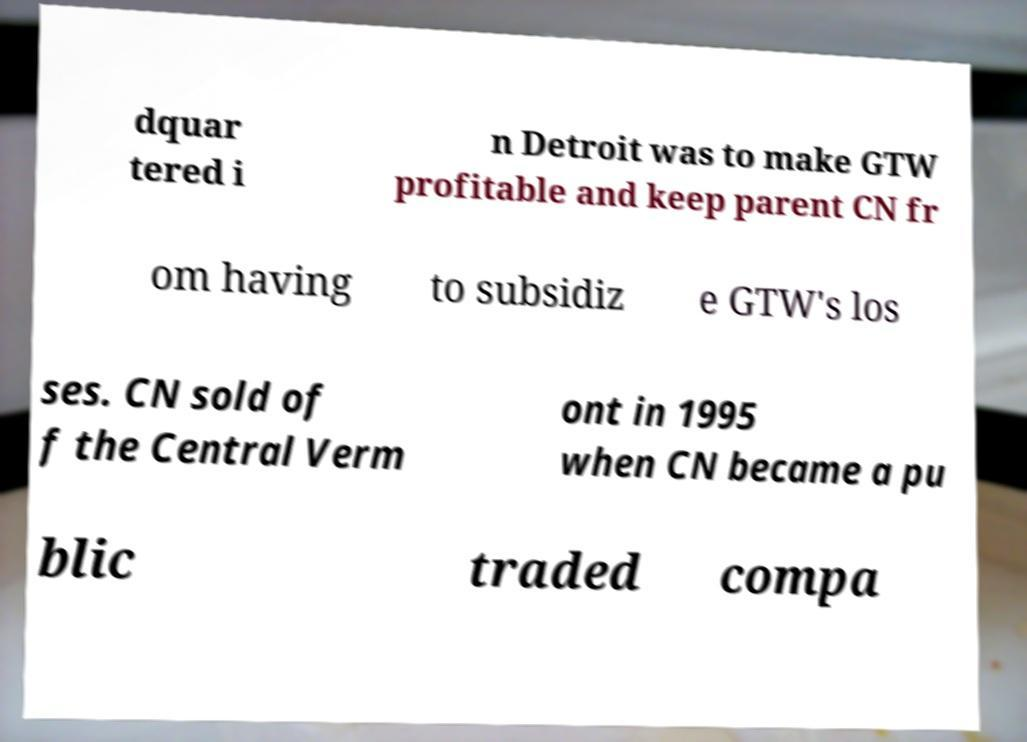There's text embedded in this image that I need extracted. Can you transcribe it verbatim? dquar tered i n Detroit was to make GTW profitable and keep parent CN fr om having to subsidiz e GTW's los ses. CN sold of f the Central Verm ont in 1995 when CN became a pu blic traded compa 